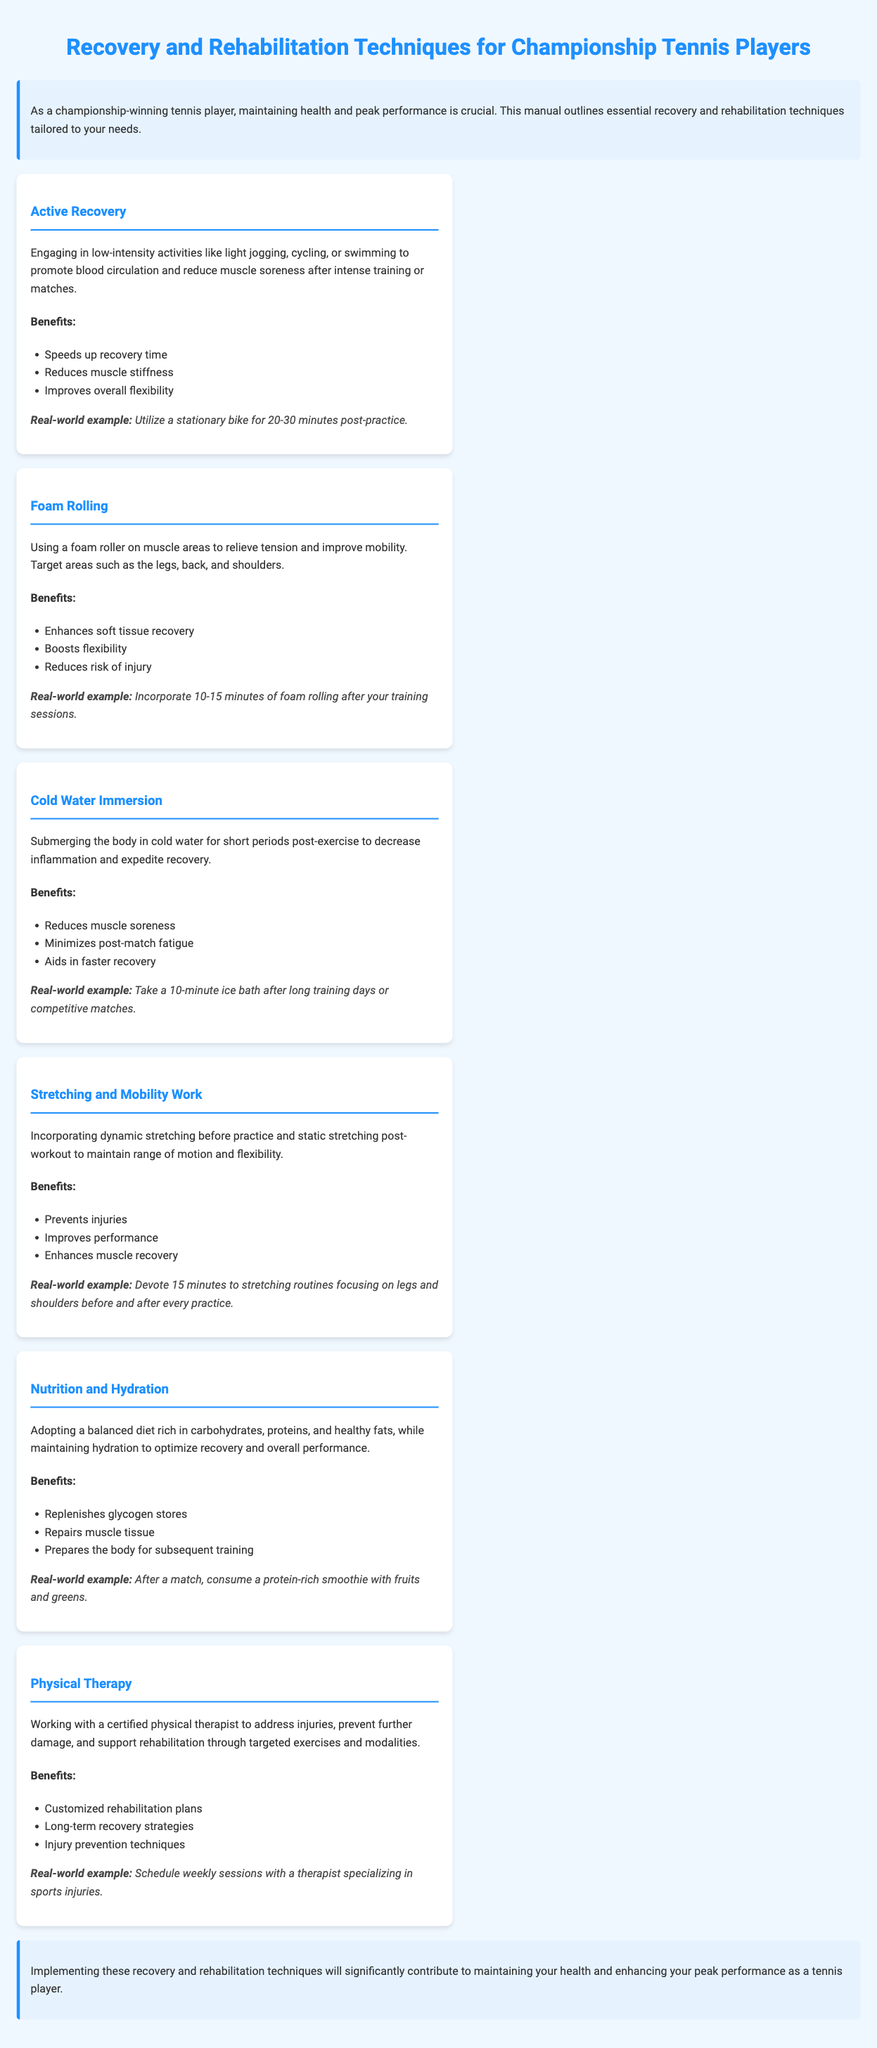what is the title of the manual? The title of the manual is prominently displayed at the top of the document.
Answer: Recovery and Rehabilitation Techniques for Championship Tennis Players how many recovery techniques are listed? The number of techniques can be counted from the document's techniques section.
Answer: Six what is the benefit of active recovery? The benefits are listed under each recovery technique, detailing specific positive outcomes.
Answer: Speeds up recovery time what is a real-world example of cold water immersion? The real-world examples provide practical applications related to each technique.
Answer: Take a 10-minute ice bath after long training days or competitive matches what should be included in a balanced diet for optimal recovery? The document discusses nutrition, emphasizing key components.
Answer: Carbohydrates, proteins, and healthy fats who should you work with for physical therapy? The document specifies the profession relevant for rehabilitation in its physical therapy section.
Answer: Certified physical therapist what does foam rolling enhance? The benefits of foam rolling provide insight into its importance in recovery.
Answer: Soft tissue recovery how long should stretching routines be devoted to? The document states a specific time allocation for stretching routines.
Answer: 15 minutes 